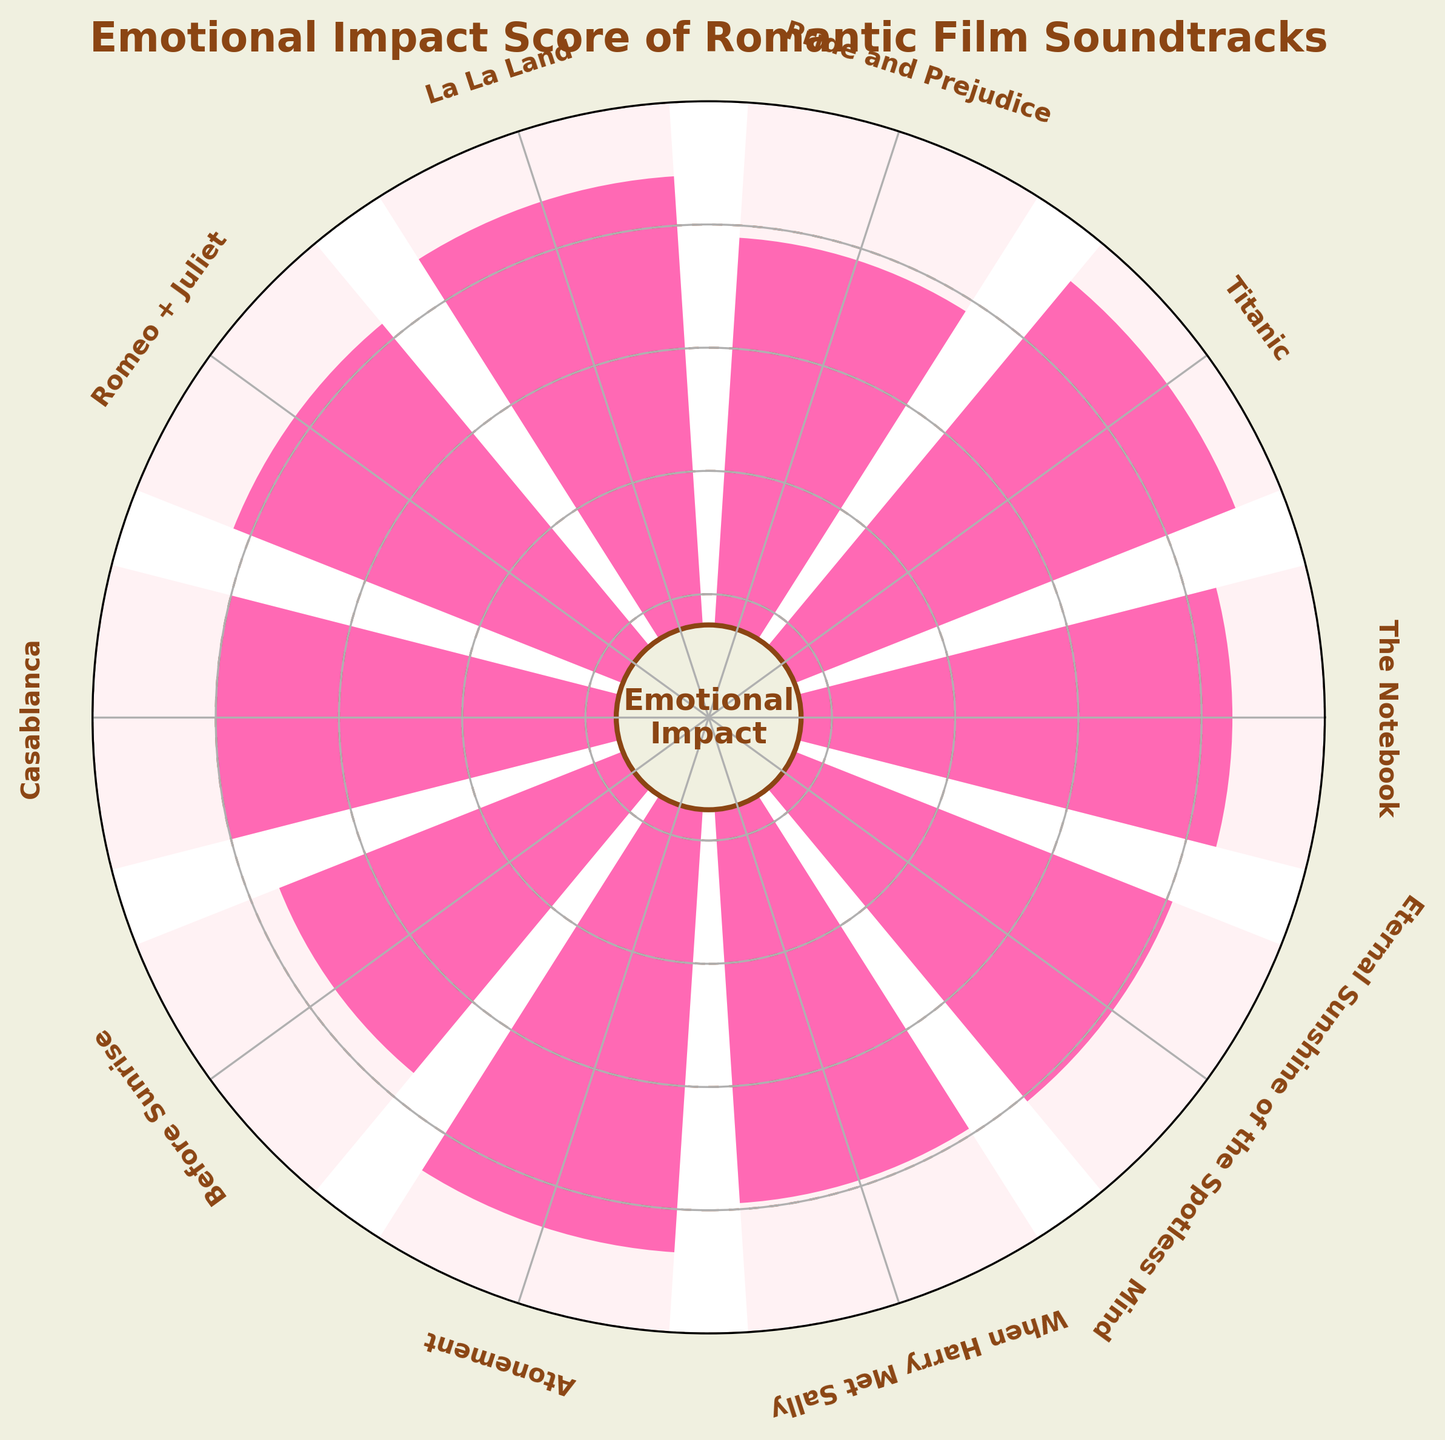What is the title of the figure? The title of the figure is prominently displayed at the top of the chart. It reads, "Emotional Impact Score of Romantic Film Soundtracks."
Answer: Emotional Impact Score of Romantic Film Soundtracks How many soundtracks are analyzed in the figure? The radial arrangement of bars and the number of titles around the chart indicate the total count. Each bar represents one soundtrack. Counting these bars reveals there are 10 soundtracks.
Answer: 10 Which soundtrack has the highest emotional impact score? By identifying the longest bar in the chart, which extends out the most from the center, we see that the soundtrack "Titanic" has the longest bar, thus the highest impact score.
Answer: Titanic What is the emotional impact score of "Pride and Prejudice"? Locate the "Pride and Prejudice" label on the chart. The bar corresponding to this label extends to a certain point, which, by visual inspection, is approximately at the 78% mark on the circular gauge.
Answer: 78 Compare the emotional impact scores of "When Harry Met Sally" and "Casablanca". Which one is higher? Observe the lengths of the bars corresponding to "When Harry Met Sally" and "Casablanca". "Casablanca" has a score of 80, whereas "When Harry Met Sally" has a score of 79. Thus, "Casablanca" is higher.
Answer: Casablanca Calculate the average emotional impact score of all soundtracks. Sum each soundtrack's impact score: (85 + 92 + 78 + 88 + 83 + 80 + 75 + 87 + 79 + 81) = 828. The number of soundtracks is 10. Divide the total score by the number of soundtracks: 828 / 10 = 82.8
Answer: 82.8 What is the difference between the highest and the lowest emotional impact scores? Identify the highest score (Titanic: 92) and the lowest score (Before Sunrise: 75). Subtract the lowest from the highest: 92 - 75 = 17.
Answer: 17 Are there more soundtracks with a score above 80 or below 80? Count the number of bars that extend beyond the 80% mark and those that do not. There are 6 soundtracks above 80 (The Notebook, Titanic, La La Land, Romeo + Juliet, Atonement, Eternal Sunshine of the Spotless Mind) and 4 below 80 (Pride and Prejudice, Casablanca, Before Sunrise, When Harry Met Sally). More are above 80.
Answer: Above 80 Which soundtrack has an impact score closest to the median score of all soundtracks? Median score of sorted list [75, 78, 79, 80, 81, 83, 85, 87, 88, 92] = (81 + 83) / 2 = 82. Looking at the scores, "Eternal Sunshine of the Spotless Mind" has a score of 81 which is closest to 82.
Answer: Eternal Sunshine of the Spotless Mind What color represents the higher impact score sections on the charts? Observe the bars and ascertain the color coding. The sections representing higher scores are in a more saturated pink color. The higher impact sections use a bright pink color.
Answer: Bright pink 